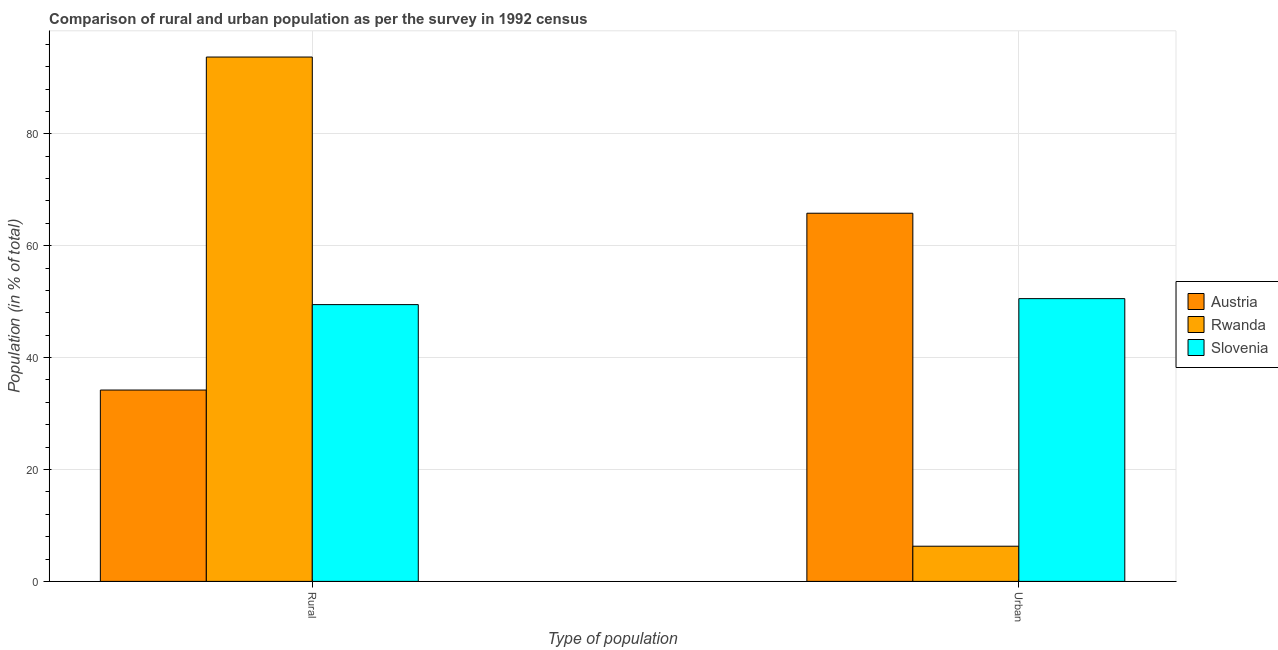How many different coloured bars are there?
Provide a short and direct response. 3. How many groups of bars are there?
Your response must be concise. 2. Are the number of bars per tick equal to the number of legend labels?
Provide a succinct answer. Yes. Are the number of bars on each tick of the X-axis equal?
Offer a terse response. Yes. How many bars are there on the 2nd tick from the left?
Offer a very short reply. 3. What is the label of the 2nd group of bars from the left?
Offer a terse response. Urban. What is the rural population in Rwanda?
Provide a short and direct response. 93.71. Across all countries, what is the maximum urban population?
Provide a succinct answer. 65.8. Across all countries, what is the minimum urban population?
Your answer should be very brief. 6.29. In which country was the rural population maximum?
Provide a short and direct response. Rwanda. In which country was the urban population minimum?
Your answer should be compact. Rwanda. What is the total rural population in the graph?
Ensure brevity in your answer.  177.38. What is the difference between the rural population in Slovenia and that in Rwanda?
Keep it short and to the point. -44.25. What is the difference between the rural population in Slovenia and the urban population in Rwanda?
Give a very brief answer. 43.18. What is the average urban population per country?
Offer a very short reply. 40.87. What is the difference between the rural population and urban population in Rwanda?
Your answer should be compact. 87.42. In how many countries, is the rural population greater than 28 %?
Provide a short and direct response. 3. What is the ratio of the urban population in Austria to that in Rwanda?
Provide a short and direct response. 10.46. In how many countries, is the urban population greater than the average urban population taken over all countries?
Give a very brief answer. 2. What does the 2nd bar from the left in Rural represents?
Offer a very short reply. Rwanda. What does the 3rd bar from the right in Rural represents?
Give a very brief answer. Austria. Are all the bars in the graph horizontal?
Provide a short and direct response. No. How many countries are there in the graph?
Your answer should be very brief. 3. How many legend labels are there?
Keep it short and to the point. 3. How are the legend labels stacked?
Keep it short and to the point. Vertical. What is the title of the graph?
Keep it short and to the point. Comparison of rural and urban population as per the survey in 1992 census. What is the label or title of the X-axis?
Your answer should be very brief. Type of population. What is the label or title of the Y-axis?
Offer a very short reply. Population (in % of total). What is the Population (in % of total) in Austria in Rural?
Provide a short and direct response. 34.2. What is the Population (in % of total) in Rwanda in Rural?
Your answer should be compact. 93.71. What is the Population (in % of total) of Slovenia in Rural?
Give a very brief answer. 49.47. What is the Population (in % of total) in Austria in Urban?
Offer a very short reply. 65.8. What is the Population (in % of total) of Rwanda in Urban?
Offer a very short reply. 6.29. What is the Population (in % of total) of Slovenia in Urban?
Give a very brief answer. 50.53. Across all Type of population, what is the maximum Population (in % of total) in Austria?
Your answer should be compact. 65.8. Across all Type of population, what is the maximum Population (in % of total) in Rwanda?
Your answer should be very brief. 93.71. Across all Type of population, what is the maximum Population (in % of total) in Slovenia?
Ensure brevity in your answer.  50.53. Across all Type of population, what is the minimum Population (in % of total) of Austria?
Make the answer very short. 34.2. Across all Type of population, what is the minimum Population (in % of total) of Rwanda?
Give a very brief answer. 6.29. Across all Type of population, what is the minimum Population (in % of total) in Slovenia?
Provide a short and direct response. 49.47. What is the total Population (in % of total) in Slovenia in the graph?
Your response must be concise. 100. What is the difference between the Population (in % of total) in Austria in Rural and that in Urban?
Provide a short and direct response. -31.6. What is the difference between the Population (in % of total) of Rwanda in Rural and that in Urban?
Your answer should be compact. 87.42. What is the difference between the Population (in % of total) in Slovenia in Rural and that in Urban?
Your answer should be compact. -1.07. What is the difference between the Population (in % of total) in Austria in Rural and the Population (in % of total) in Rwanda in Urban?
Make the answer very short. 27.91. What is the difference between the Population (in % of total) in Austria in Rural and the Population (in % of total) in Slovenia in Urban?
Provide a succinct answer. -16.33. What is the difference between the Population (in % of total) of Rwanda in Rural and the Population (in % of total) of Slovenia in Urban?
Your response must be concise. 43.18. What is the average Population (in % of total) in Rwanda per Type of population?
Provide a succinct answer. 50. What is the difference between the Population (in % of total) of Austria and Population (in % of total) of Rwanda in Rural?
Provide a short and direct response. -59.51. What is the difference between the Population (in % of total) in Austria and Population (in % of total) in Slovenia in Rural?
Give a very brief answer. -15.27. What is the difference between the Population (in % of total) in Rwanda and Population (in % of total) in Slovenia in Rural?
Give a very brief answer. 44.25. What is the difference between the Population (in % of total) of Austria and Population (in % of total) of Rwanda in Urban?
Offer a terse response. 59.51. What is the difference between the Population (in % of total) in Austria and Population (in % of total) in Slovenia in Urban?
Offer a very short reply. 15.27. What is the difference between the Population (in % of total) in Rwanda and Population (in % of total) in Slovenia in Urban?
Give a very brief answer. -44.25. What is the ratio of the Population (in % of total) in Austria in Rural to that in Urban?
Your answer should be very brief. 0.52. What is the ratio of the Population (in % of total) of Rwanda in Rural to that in Urban?
Offer a terse response. 14.9. What is the ratio of the Population (in % of total) in Slovenia in Rural to that in Urban?
Provide a succinct answer. 0.98. What is the difference between the highest and the second highest Population (in % of total) in Austria?
Keep it short and to the point. 31.6. What is the difference between the highest and the second highest Population (in % of total) of Rwanda?
Make the answer very short. 87.42. What is the difference between the highest and the second highest Population (in % of total) in Slovenia?
Offer a very short reply. 1.07. What is the difference between the highest and the lowest Population (in % of total) in Austria?
Provide a short and direct response. 31.6. What is the difference between the highest and the lowest Population (in % of total) of Rwanda?
Your response must be concise. 87.42. What is the difference between the highest and the lowest Population (in % of total) of Slovenia?
Give a very brief answer. 1.07. 